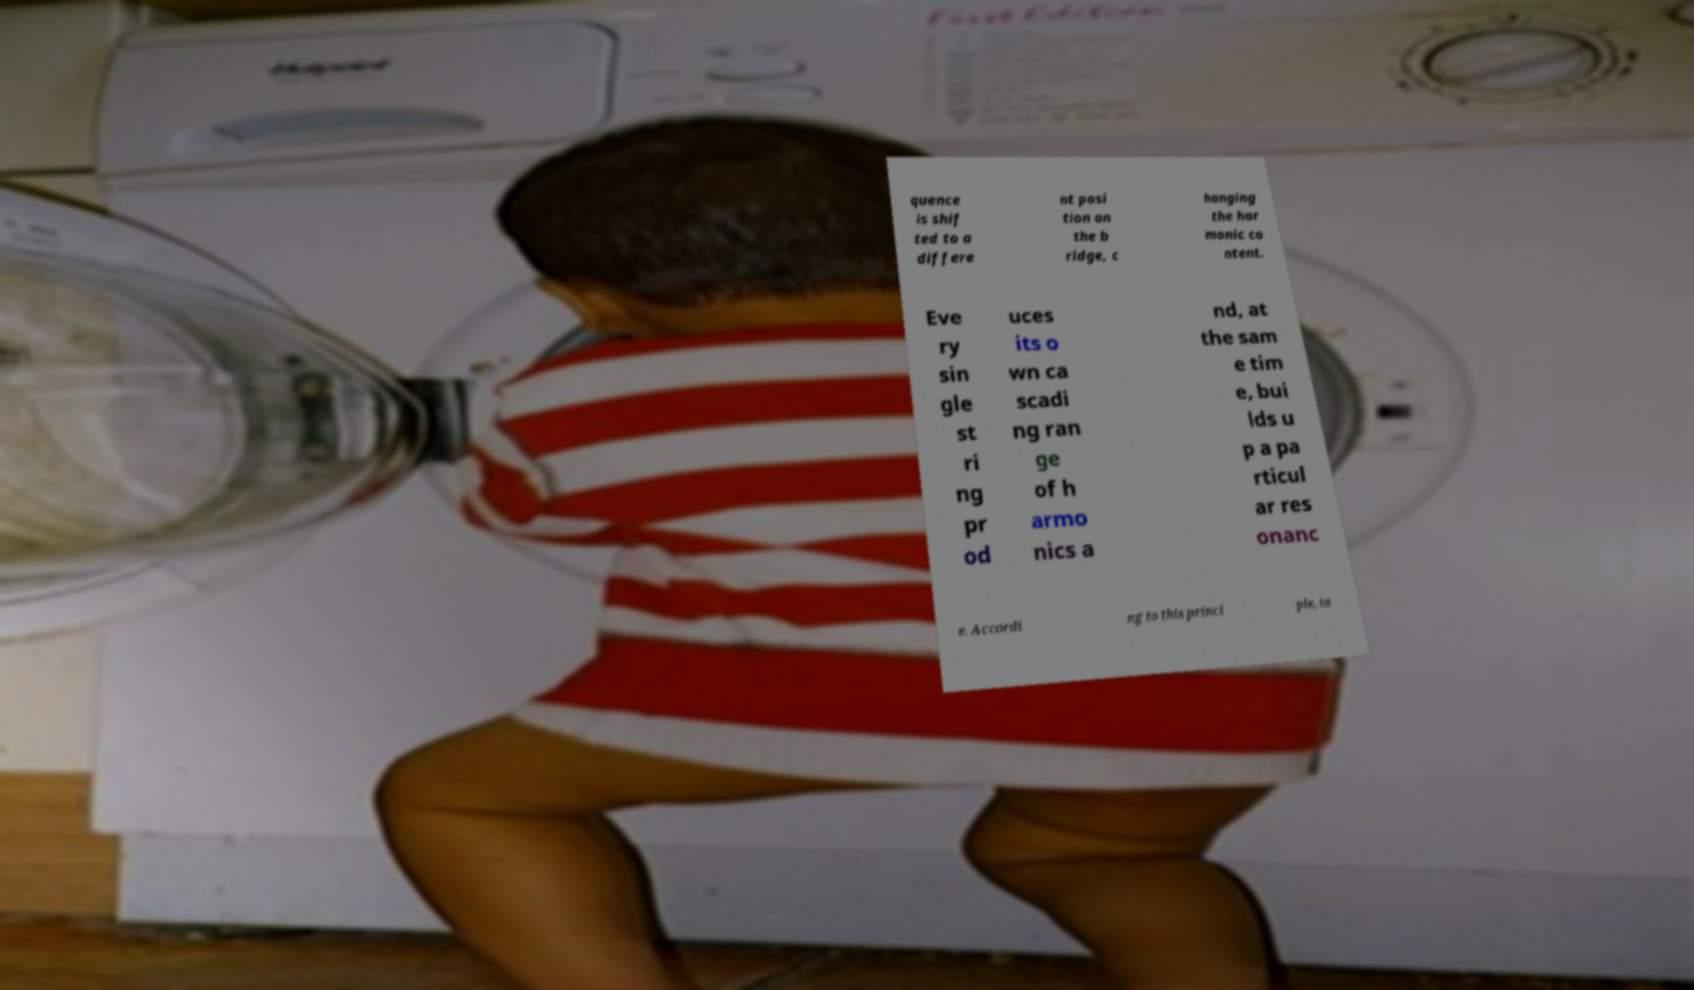Could you assist in decoding the text presented in this image and type it out clearly? quence is shif ted to a differe nt posi tion on the b ridge, c hanging the har monic co ntent. Eve ry sin gle st ri ng pr od uces its o wn ca scadi ng ran ge of h armo nics a nd, at the sam e tim e, bui lds u p a pa rticul ar res onanc e. Accordi ng to this princi ple, ta 